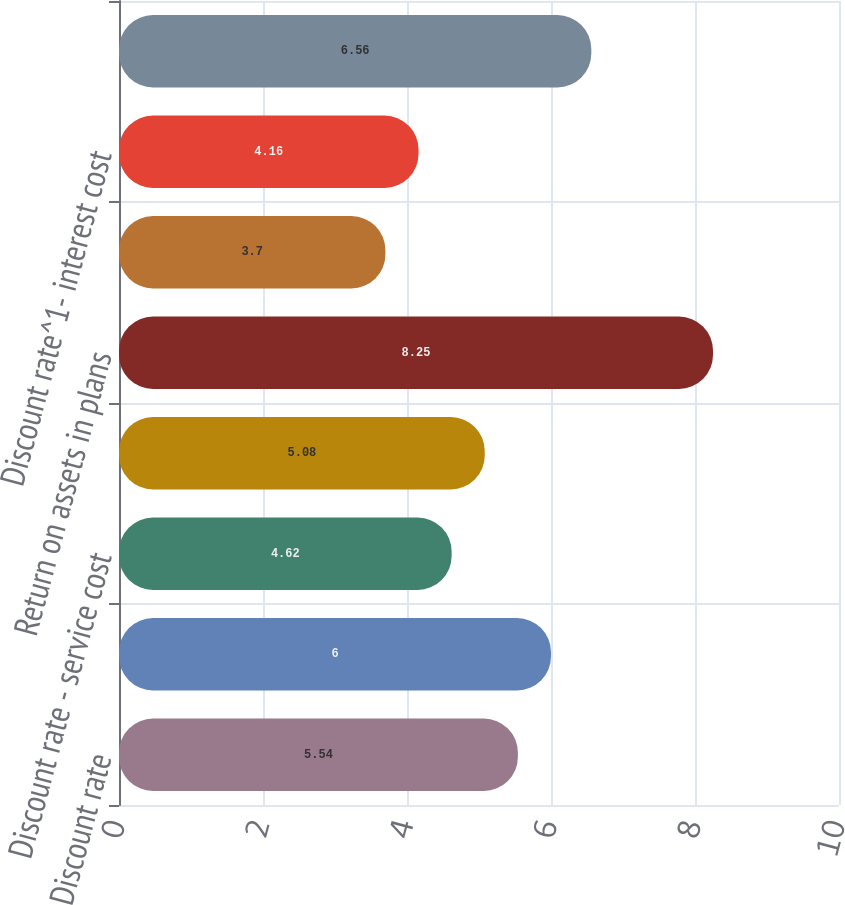Convert chart to OTSL. <chart><loc_0><loc_0><loc_500><loc_500><bar_chart><fcel>Discount rate<fcel>Future salary increases<fcel>Discount rate - service cost<fcel>Discount rate - interest cost<fcel>Return on assets in plans<fcel>Discount rate^1 - service cost<fcel>Discount rate^1- interest cost<fcel>Health care trend rate<nl><fcel>5.54<fcel>6<fcel>4.62<fcel>5.08<fcel>8.25<fcel>3.7<fcel>4.16<fcel>6.56<nl></chart> 